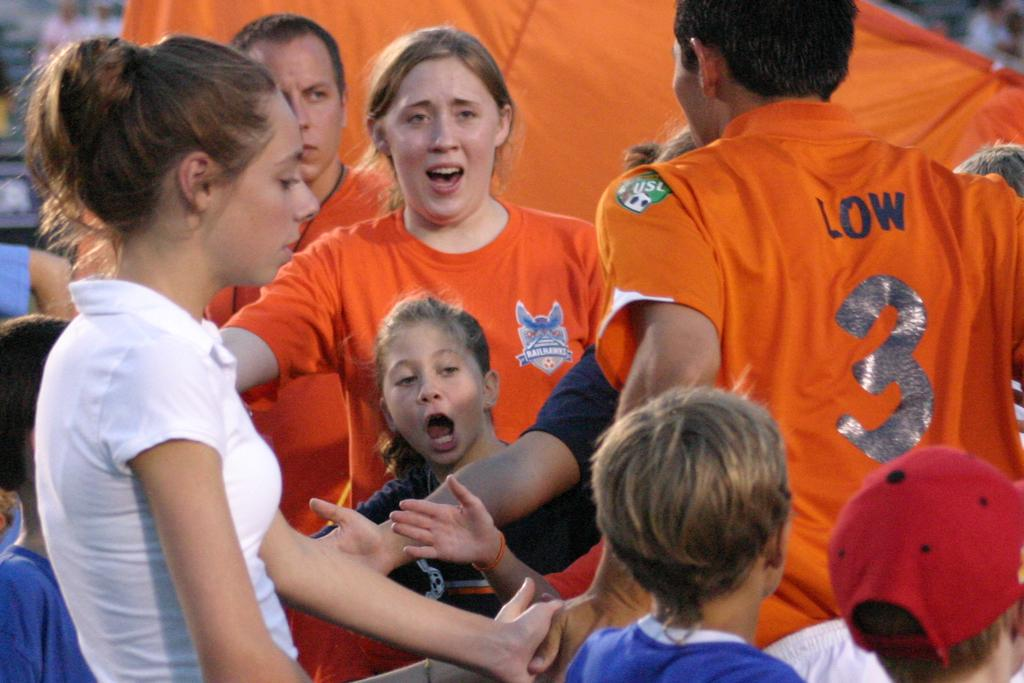<image>
Write a terse but informative summary of the picture. the word low that is on the back of a jersey 